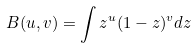Convert formula to latex. <formula><loc_0><loc_0><loc_500><loc_500>B ( u , v ) = \int z ^ { u } ( 1 - z ) ^ { v } d z</formula> 